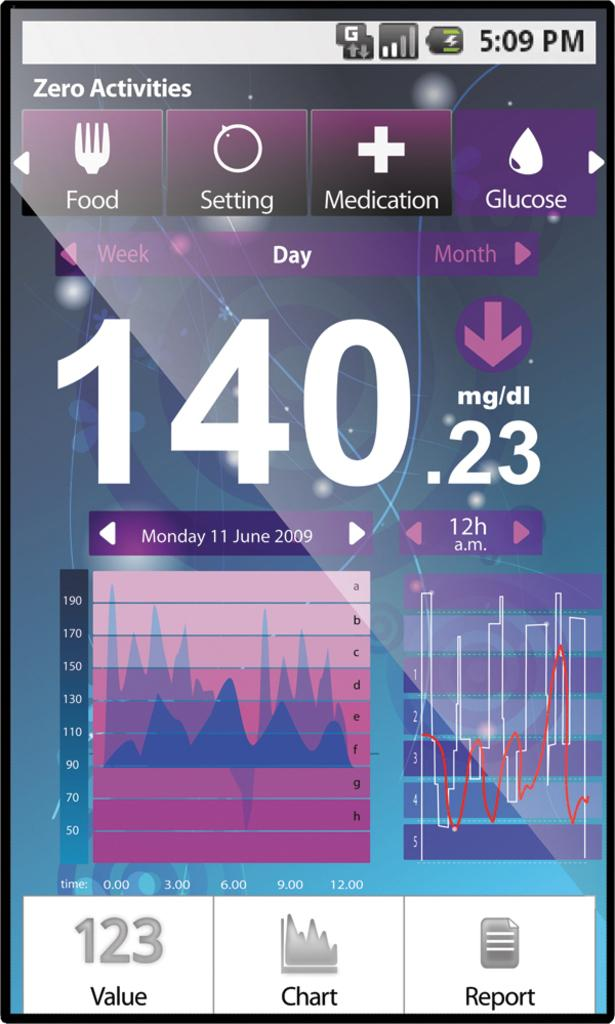Provide a one-sentence caption for the provided image. An app on a phone displays the glucose level of someone as 140.23 mg/dl. 